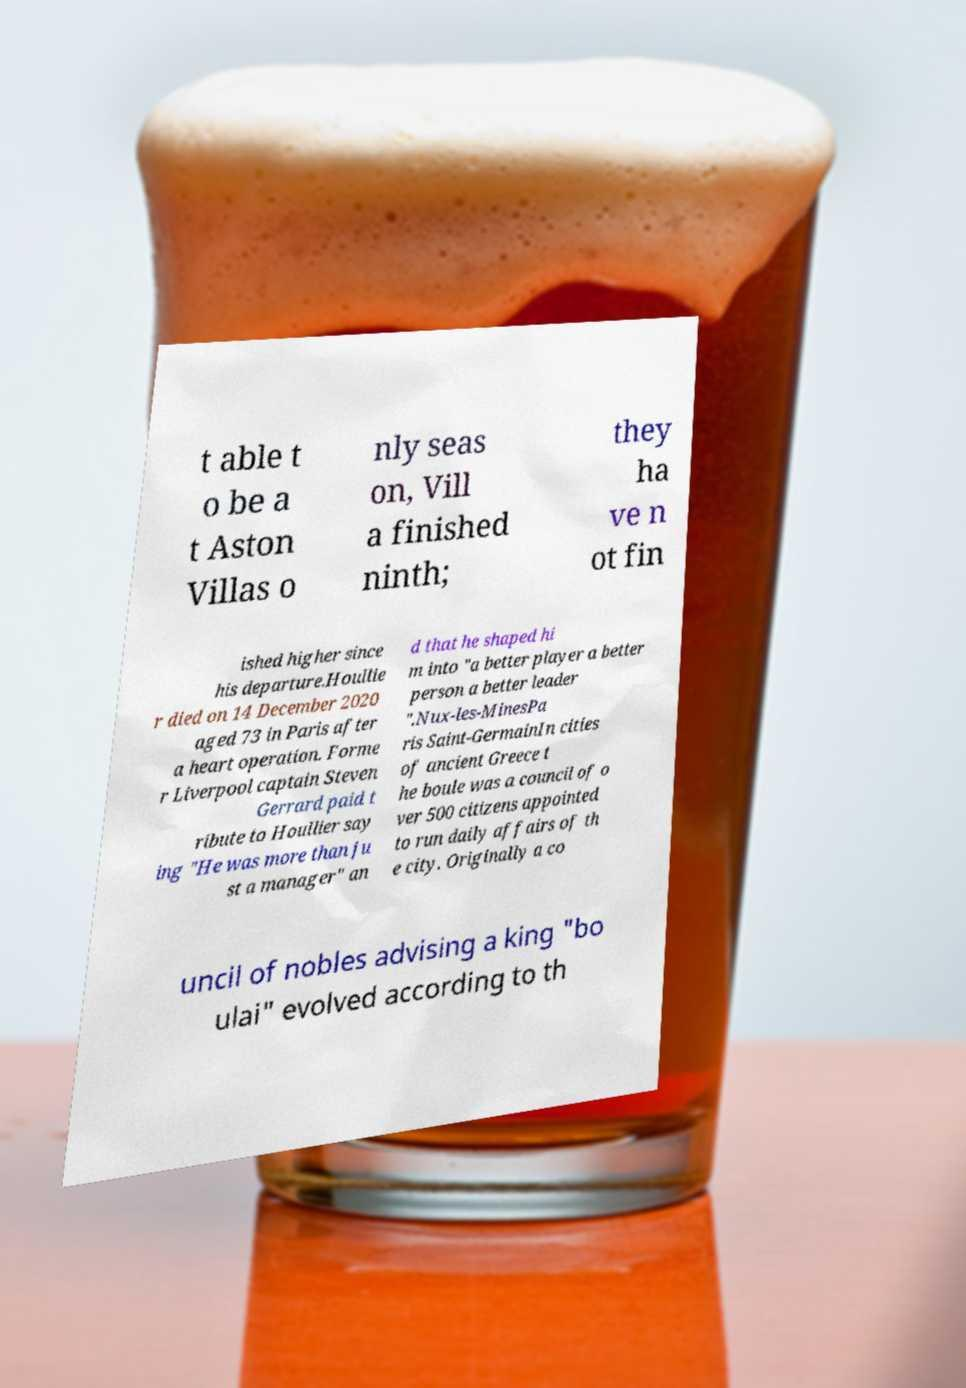There's text embedded in this image that I need extracted. Can you transcribe it verbatim? t able t o be a t Aston Villas o nly seas on, Vill a finished ninth; they ha ve n ot fin ished higher since his departure.Houllie r died on 14 December 2020 aged 73 in Paris after a heart operation. Forme r Liverpool captain Steven Gerrard paid t ribute to Houllier say ing "He was more than ju st a manager" an d that he shaped hi m into "a better player a better person a better leader ".Nux-les-MinesPa ris Saint-GermainIn cities of ancient Greece t he boule was a council of o ver 500 citizens appointed to run daily affairs of th e city. Originally a co uncil of nobles advising a king "bo ulai" evolved according to th 